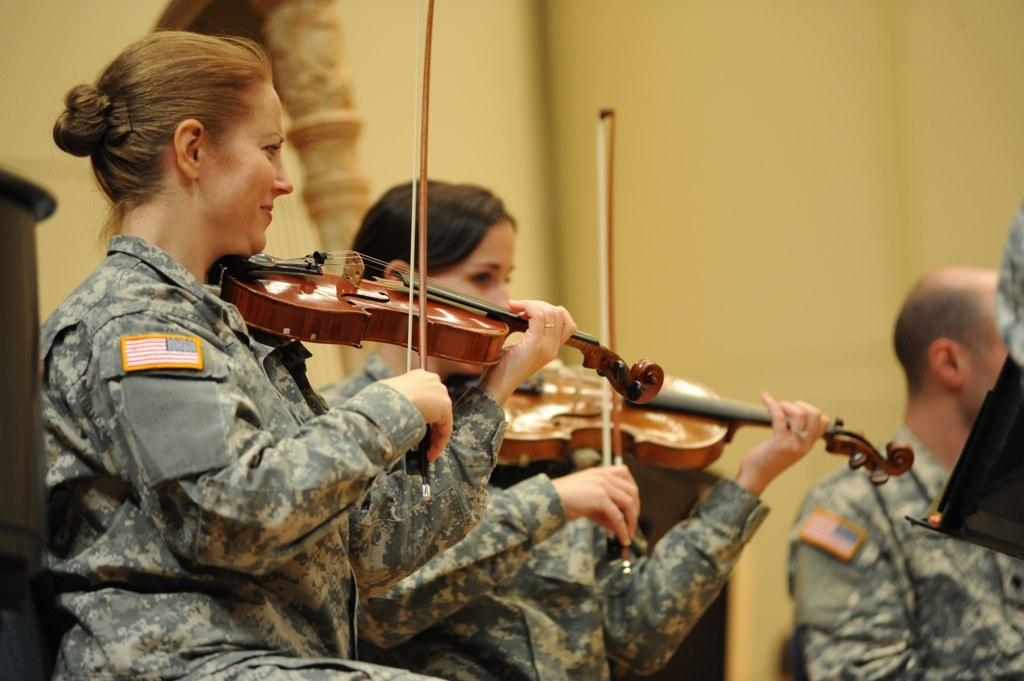What are the people in the image doing? There are persons sitting in the image, and two of them are playing musical instruments. Can you describe the background of the image? There is a wall in the background of the image. What type of berry can be seen in the hands of the person playing the musical instrument? There is no berry present in the image; the persons are playing musical instruments. What kind of harmony is being created by the persons playing the musical instruments? The image does not provide information about the harmony created by the musical instruments, as it only shows the persons playing them. 